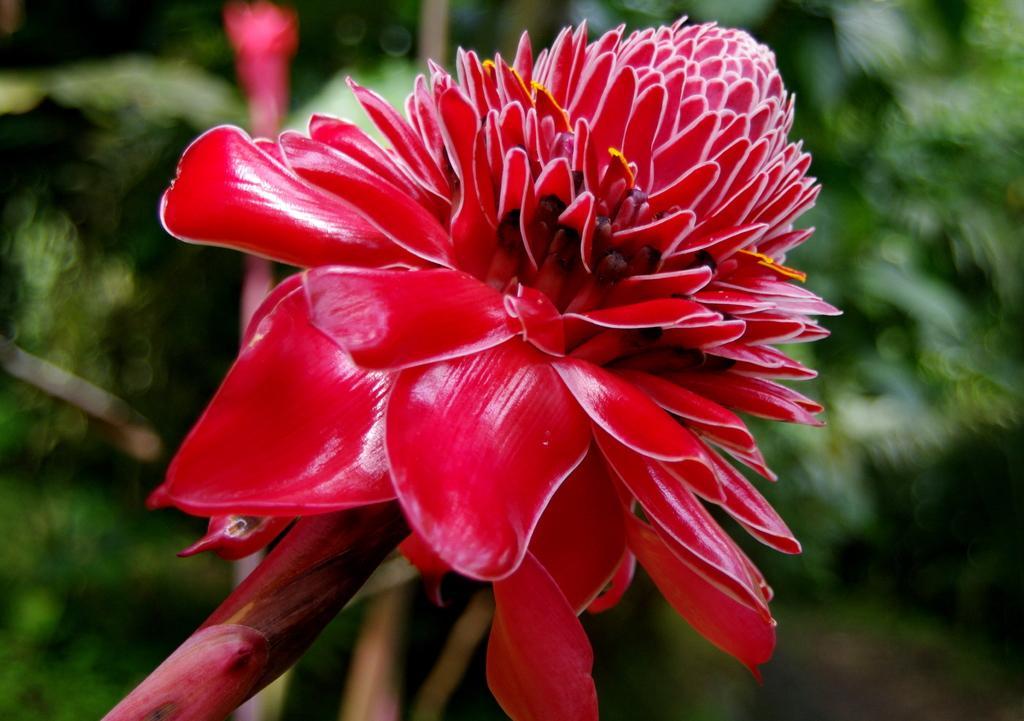Can you describe this image briefly? In the middle of this image, there is a red color flower of a plant. And the background is blurred. 